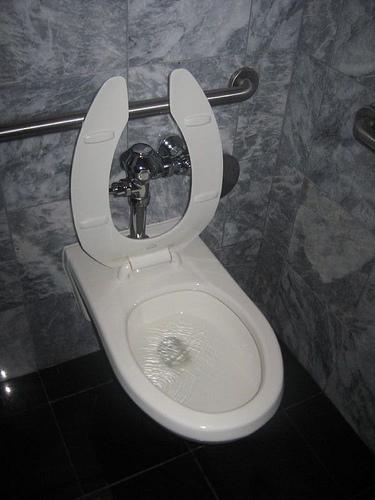Where is the rest of the toilet?
Answer briefly. In wall. Does the toilet have a design on the inside?
Quick response, please. No. What do people have to do to sit on the toilet comfortably?
Concise answer only. Put seat down. What era of art style is the toilet from?
Keep it brief. Modern. Is the cleanliness of this bathroom typical for a highway rest stop?
Keep it brief. No. Is there something inside the toilet?
Short answer required. No. Is the seat down?
Keep it brief. No. Is there water in the seat?
Answer briefly. Yes. 